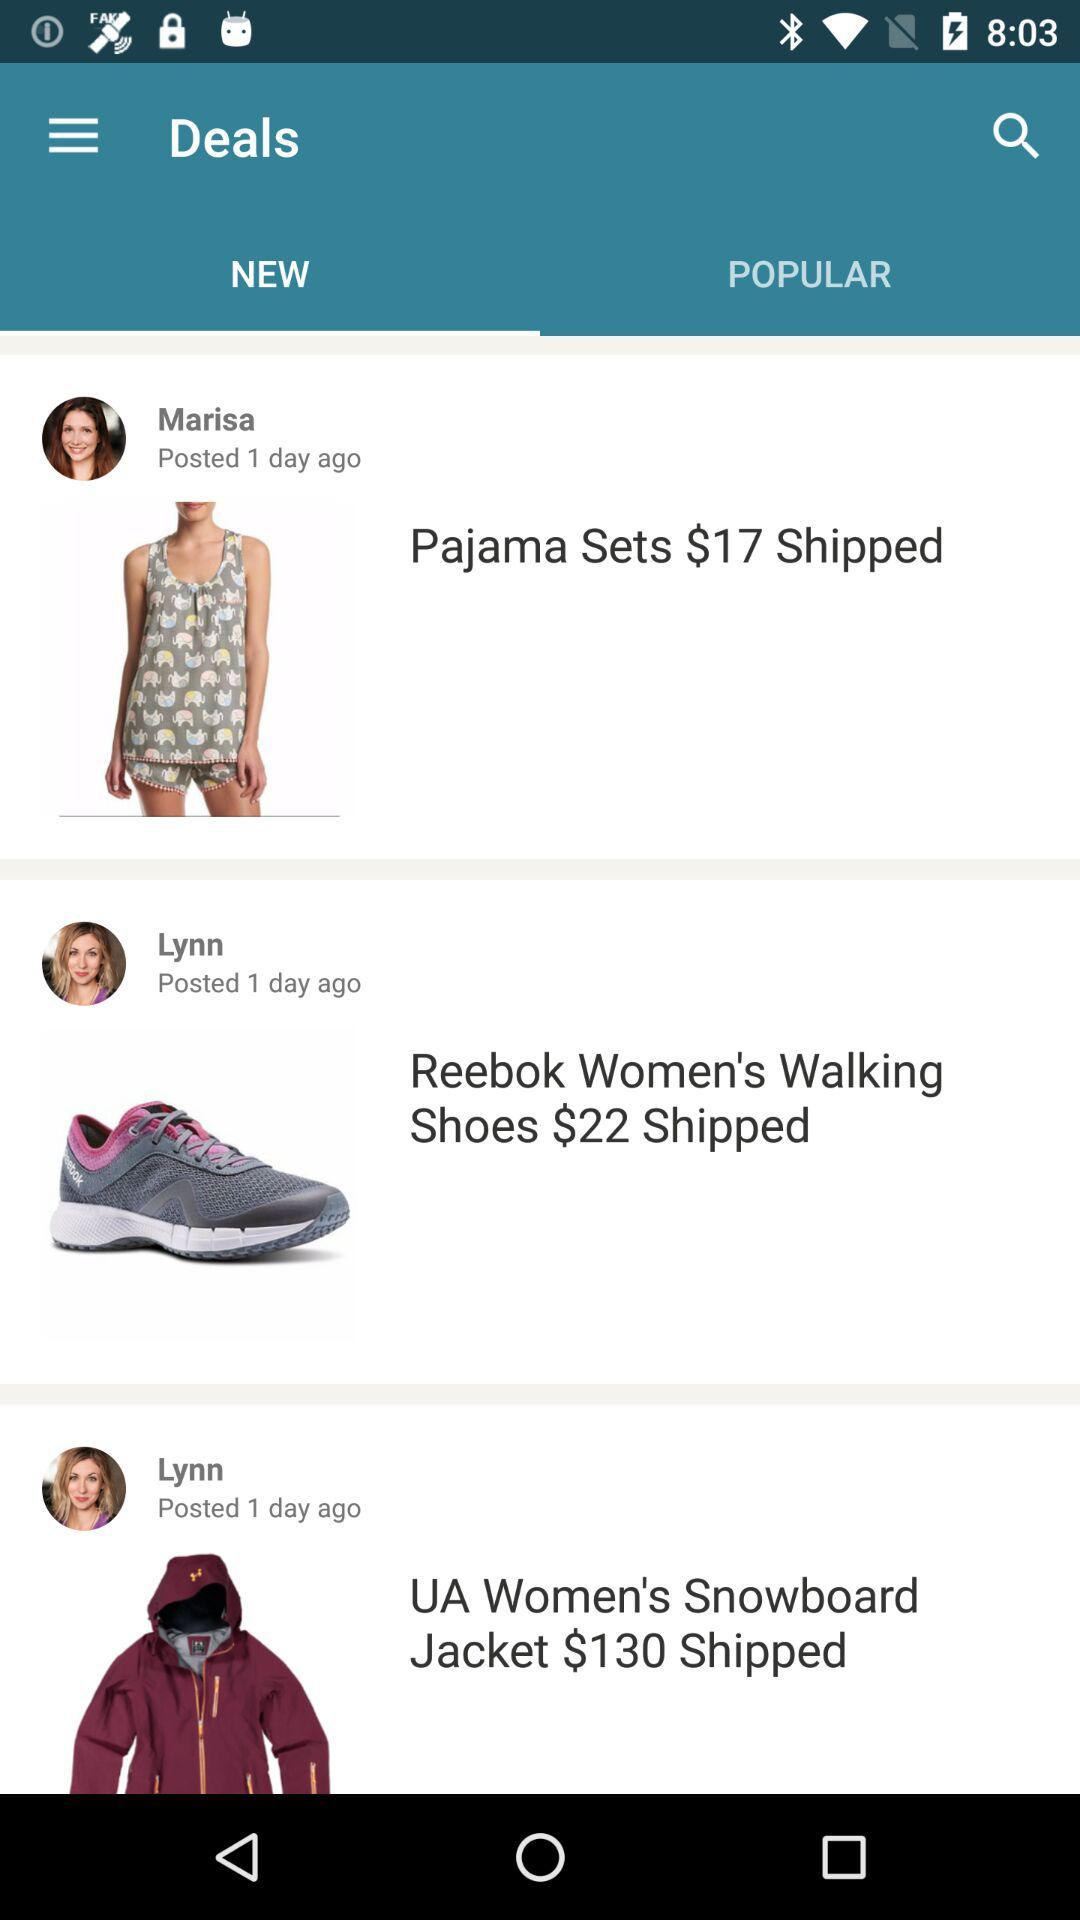What is the price of the pajama set? The price of the pajama set is $17. 